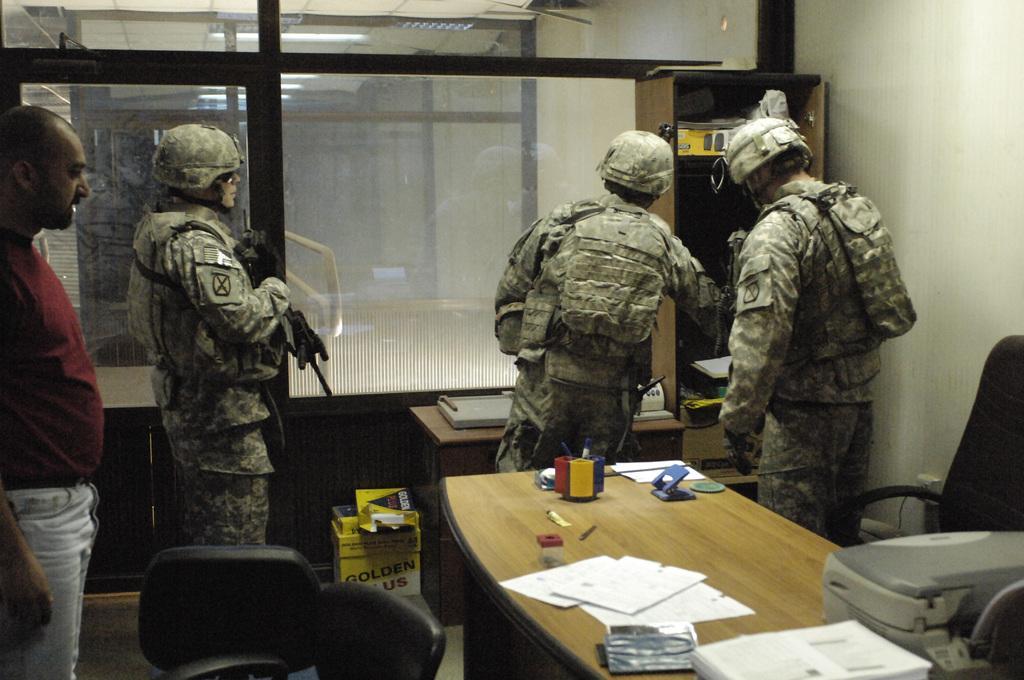Could you give a brief overview of what you see in this image? there are 4 people. 3 people at the left are wearing army uniform. the person at the right is wearing a red t shirt. in the front there is a table on which there are papers. 